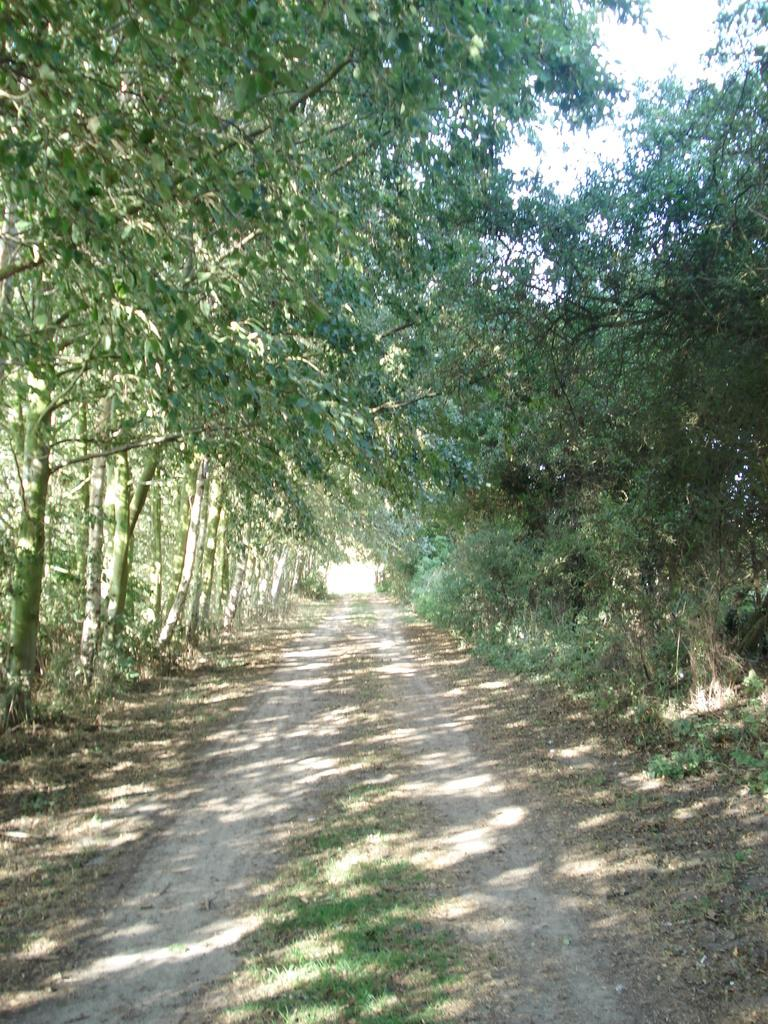What type of vegetation is present in the image? There are trees and grass in the image. What can be seen in the background of the image? The sky is visible in the background of the image. What channel is the father watching in the image? There is no father or television present in the image; it features trees, grass, and the sky. 